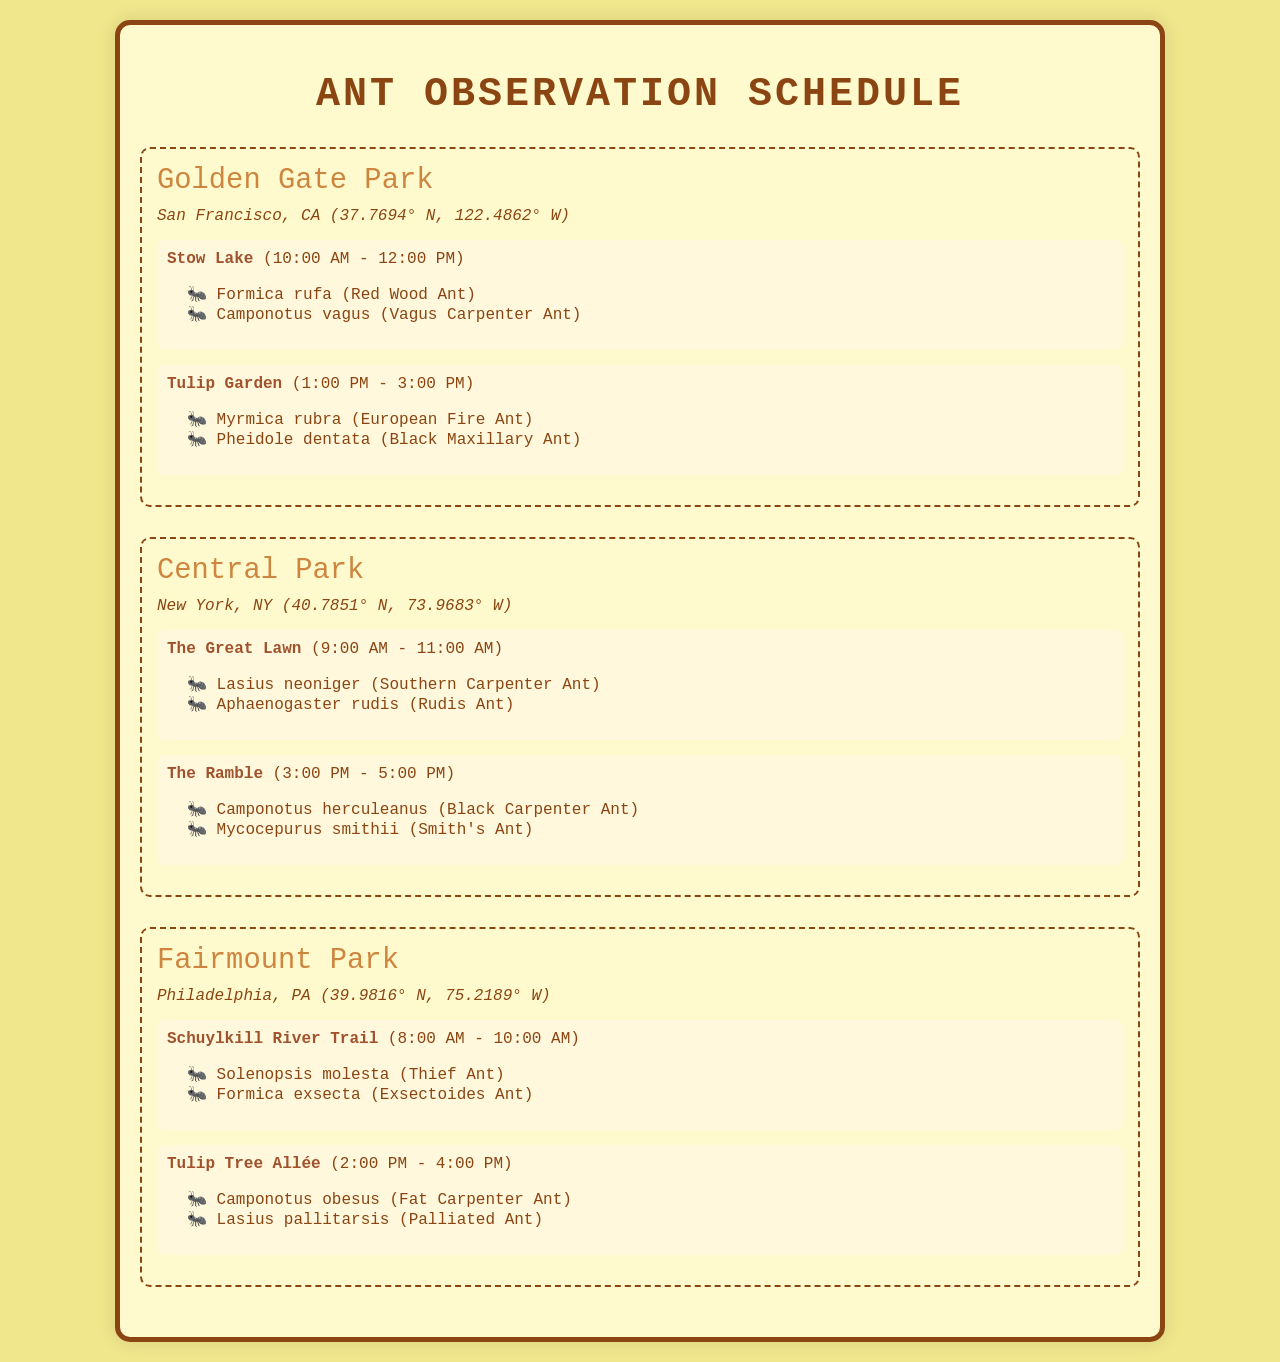What is the first observation location in Golden Gate Park? The first observation location listed in Golden Gate Park is Stow Lake, which is mentioned alongside its observation time.
Answer: Stow Lake What species are monitored at Tulip Garden? The species observed at Tulip Garden are detailed in the document and are listed in an unordered list.
Answer: Myrmica rubra, Pheidole dentata What time does the observation at The Ramble start? The Ramble's observation time is provided in the schedule format, indicating when it begins and ends.
Answer: 3:00 PM Which park is located in Philadelphia? The name of the park located in Philadelphia is explicitly mentioned in the document under the park section.
Answer: Fairmount Park How many species are observed at The Great Lawn? The total number of species is found by counting the items in the list provided for The Great Lawn.
Answer: 2 What is the observation duration for the Schuylkill River Trail? The document specifies the observation time frame for each location, from start to end time, which constitutes its duration.
Answer: 2 hours Which ant species is monitored at Central Park's The Ramble? The specific species for The Ramble observation are listed under that section in the document.
Answer: Camponotus herculeanus, Mycocepurus smithii What are the coordinates of Golden Gate Park? The geographical coordinates are explicitly stated in the park's information section within the document.
Answer: 37.7694° N, 122.4862° W 